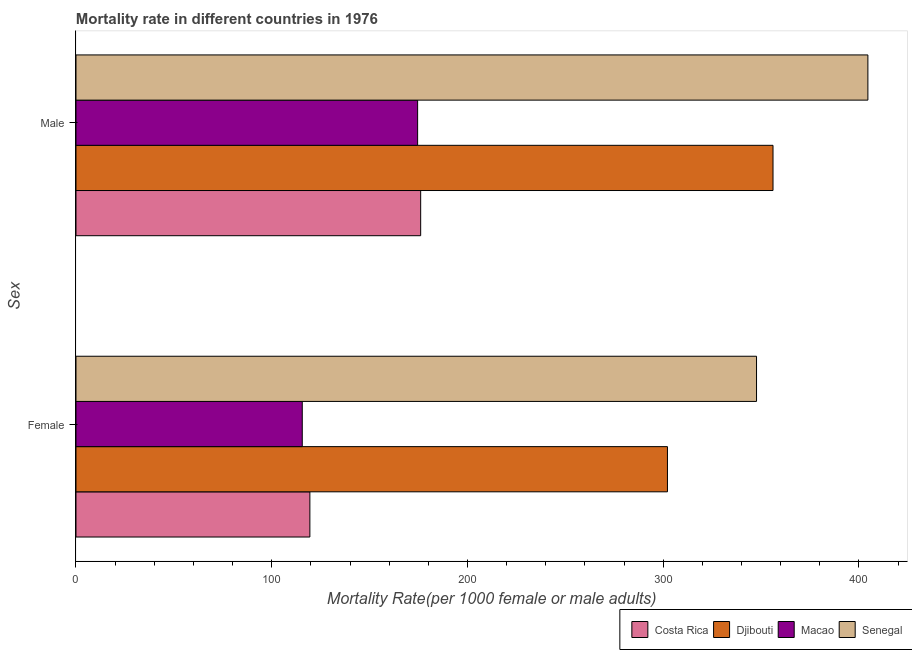How many groups of bars are there?
Your answer should be compact. 2. Are the number of bars per tick equal to the number of legend labels?
Make the answer very short. Yes. How many bars are there on the 1st tick from the top?
Your answer should be compact. 4. What is the male mortality rate in Senegal?
Your response must be concise. 404.62. Across all countries, what is the maximum female mortality rate?
Provide a short and direct response. 347.72. Across all countries, what is the minimum male mortality rate?
Keep it short and to the point. 174.55. In which country was the male mortality rate maximum?
Your response must be concise. Senegal. In which country was the male mortality rate minimum?
Give a very brief answer. Macao. What is the total male mortality rate in the graph?
Provide a short and direct response. 1111.42. What is the difference between the male mortality rate in Costa Rica and that in Senegal?
Provide a short and direct response. -228.51. What is the difference between the male mortality rate in Costa Rica and the female mortality rate in Senegal?
Give a very brief answer. -171.61. What is the average male mortality rate per country?
Your answer should be very brief. 277.85. What is the difference between the male mortality rate and female mortality rate in Costa Rica?
Give a very brief answer. 56.61. In how many countries, is the female mortality rate greater than 180 ?
Ensure brevity in your answer.  2. What is the ratio of the female mortality rate in Costa Rica to that in Senegal?
Provide a succinct answer. 0.34. Is the female mortality rate in Costa Rica less than that in Djibouti?
Make the answer very short. Yes. In how many countries, is the female mortality rate greater than the average female mortality rate taken over all countries?
Ensure brevity in your answer.  2. What does the 2nd bar from the top in Male represents?
Ensure brevity in your answer.  Macao. Are all the bars in the graph horizontal?
Offer a terse response. Yes. How many countries are there in the graph?
Your answer should be very brief. 4. What is the difference between two consecutive major ticks on the X-axis?
Provide a succinct answer. 100. Are the values on the major ticks of X-axis written in scientific E-notation?
Provide a succinct answer. No. Does the graph contain any zero values?
Your answer should be compact. No. Does the graph contain grids?
Provide a succinct answer. No. How many legend labels are there?
Give a very brief answer. 4. How are the legend labels stacked?
Give a very brief answer. Horizontal. What is the title of the graph?
Provide a short and direct response. Mortality rate in different countries in 1976. Does "Netherlands" appear as one of the legend labels in the graph?
Offer a very short reply. No. What is the label or title of the X-axis?
Give a very brief answer. Mortality Rate(per 1000 female or male adults). What is the label or title of the Y-axis?
Your answer should be very brief. Sex. What is the Mortality Rate(per 1000 female or male adults) of Costa Rica in Female?
Offer a terse response. 119.5. What is the Mortality Rate(per 1000 female or male adults) in Djibouti in Female?
Offer a very short reply. 302.2. What is the Mortality Rate(per 1000 female or male adults) of Macao in Female?
Offer a terse response. 115.61. What is the Mortality Rate(per 1000 female or male adults) of Senegal in Female?
Your response must be concise. 347.72. What is the Mortality Rate(per 1000 female or male adults) in Costa Rica in Male?
Offer a very short reply. 176.11. What is the Mortality Rate(per 1000 female or male adults) of Djibouti in Male?
Provide a succinct answer. 356.14. What is the Mortality Rate(per 1000 female or male adults) of Macao in Male?
Ensure brevity in your answer.  174.55. What is the Mortality Rate(per 1000 female or male adults) of Senegal in Male?
Keep it short and to the point. 404.62. Across all Sex, what is the maximum Mortality Rate(per 1000 female or male adults) of Costa Rica?
Offer a very short reply. 176.11. Across all Sex, what is the maximum Mortality Rate(per 1000 female or male adults) of Djibouti?
Keep it short and to the point. 356.14. Across all Sex, what is the maximum Mortality Rate(per 1000 female or male adults) of Macao?
Ensure brevity in your answer.  174.55. Across all Sex, what is the maximum Mortality Rate(per 1000 female or male adults) in Senegal?
Offer a terse response. 404.62. Across all Sex, what is the minimum Mortality Rate(per 1000 female or male adults) of Costa Rica?
Make the answer very short. 119.5. Across all Sex, what is the minimum Mortality Rate(per 1000 female or male adults) in Djibouti?
Your answer should be compact. 302.2. Across all Sex, what is the minimum Mortality Rate(per 1000 female or male adults) in Macao?
Offer a terse response. 115.61. Across all Sex, what is the minimum Mortality Rate(per 1000 female or male adults) of Senegal?
Your answer should be compact. 347.72. What is the total Mortality Rate(per 1000 female or male adults) of Costa Rica in the graph?
Ensure brevity in your answer.  295.61. What is the total Mortality Rate(per 1000 female or male adults) in Djibouti in the graph?
Provide a succinct answer. 658.34. What is the total Mortality Rate(per 1000 female or male adults) of Macao in the graph?
Provide a succinct answer. 290.16. What is the total Mortality Rate(per 1000 female or male adults) of Senegal in the graph?
Your answer should be very brief. 752.34. What is the difference between the Mortality Rate(per 1000 female or male adults) in Costa Rica in Female and that in Male?
Offer a terse response. -56.61. What is the difference between the Mortality Rate(per 1000 female or male adults) of Djibouti in Female and that in Male?
Give a very brief answer. -53.93. What is the difference between the Mortality Rate(per 1000 female or male adults) of Macao in Female and that in Male?
Ensure brevity in your answer.  -58.94. What is the difference between the Mortality Rate(per 1000 female or male adults) of Senegal in Female and that in Male?
Your answer should be very brief. -56.9. What is the difference between the Mortality Rate(per 1000 female or male adults) in Costa Rica in Female and the Mortality Rate(per 1000 female or male adults) in Djibouti in Male?
Keep it short and to the point. -236.64. What is the difference between the Mortality Rate(per 1000 female or male adults) of Costa Rica in Female and the Mortality Rate(per 1000 female or male adults) of Macao in Male?
Offer a terse response. -55.05. What is the difference between the Mortality Rate(per 1000 female or male adults) of Costa Rica in Female and the Mortality Rate(per 1000 female or male adults) of Senegal in Male?
Offer a terse response. -285.12. What is the difference between the Mortality Rate(per 1000 female or male adults) of Djibouti in Female and the Mortality Rate(per 1000 female or male adults) of Macao in Male?
Ensure brevity in your answer.  127.65. What is the difference between the Mortality Rate(per 1000 female or male adults) in Djibouti in Female and the Mortality Rate(per 1000 female or male adults) in Senegal in Male?
Your answer should be compact. -102.41. What is the difference between the Mortality Rate(per 1000 female or male adults) in Macao in Female and the Mortality Rate(per 1000 female or male adults) in Senegal in Male?
Provide a succinct answer. -289.01. What is the average Mortality Rate(per 1000 female or male adults) in Costa Rica per Sex?
Offer a terse response. 147.8. What is the average Mortality Rate(per 1000 female or male adults) in Djibouti per Sex?
Your answer should be very brief. 329.17. What is the average Mortality Rate(per 1000 female or male adults) in Macao per Sex?
Offer a very short reply. 145.08. What is the average Mortality Rate(per 1000 female or male adults) of Senegal per Sex?
Give a very brief answer. 376.17. What is the difference between the Mortality Rate(per 1000 female or male adults) in Costa Rica and Mortality Rate(per 1000 female or male adults) in Djibouti in Female?
Your response must be concise. -182.71. What is the difference between the Mortality Rate(per 1000 female or male adults) of Costa Rica and Mortality Rate(per 1000 female or male adults) of Macao in Female?
Give a very brief answer. 3.89. What is the difference between the Mortality Rate(per 1000 female or male adults) in Costa Rica and Mortality Rate(per 1000 female or male adults) in Senegal in Female?
Make the answer very short. -228.22. What is the difference between the Mortality Rate(per 1000 female or male adults) of Djibouti and Mortality Rate(per 1000 female or male adults) of Macao in Female?
Offer a very short reply. 186.59. What is the difference between the Mortality Rate(per 1000 female or male adults) of Djibouti and Mortality Rate(per 1000 female or male adults) of Senegal in Female?
Provide a succinct answer. -45.51. What is the difference between the Mortality Rate(per 1000 female or male adults) of Macao and Mortality Rate(per 1000 female or male adults) of Senegal in Female?
Provide a short and direct response. -232.11. What is the difference between the Mortality Rate(per 1000 female or male adults) of Costa Rica and Mortality Rate(per 1000 female or male adults) of Djibouti in Male?
Offer a very short reply. -180.03. What is the difference between the Mortality Rate(per 1000 female or male adults) of Costa Rica and Mortality Rate(per 1000 female or male adults) of Macao in Male?
Your response must be concise. 1.56. What is the difference between the Mortality Rate(per 1000 female or male adults) in Costa Rica and Mortality Rate(per 1000 female or male adults) in Senegal in Male?
Make the answer very short. -228.51. What is the difference between the Mortality Rate(per 1000 female or male adults) in Djibouti and Mortality Rate(per 1000 female or male adults) in Macao in Male?
Your answer should be compact. 181.59. What is the difference between the Mortality Rate(per 1000 female or male adults) in Djibouti and Mortality Rate(per 1000 female or male adults) in Senegal in Male?
Offer a terse response. -48.48. What is the difference between the Mortality Rate(per 1000 female or male adults) in Macao and Mortality Rate(per 1000 female or male adults) in Senegal in Male?
Provide a succinct answer. -230.07. What is the ratio of the Mortality Rate(per 1000 female or male adults) in Costa Rica in Female to that in Male?
Give a very brief answer. 0.68. What is the ratio of the Mortality Rate(per 1000 female or male adults) of Djibouti in Female to that in Male?
Your response must be concise. 0.85. What is the ratio of the Mortality Rate(per 1000 female or male adults) in Macao in Female to that in Male?
Offer a terse response. 0.66. What is the ratio of the Mortality Rate(per 1000 female or male adults) in Senegal in Female to that in Male?
Make the answer very short. 0.86. What is the difference between the highest and the second highest Mortality Rate(per 1000 female or male adults) of Costa Rica?
Offer a very short reply. 56.61. What is the difference between the highest and the second highest Mortality Rate(per 1000 female or male adults) of Djibouti?
Keep it short and to the point. 53.93. What is the difference between the highest and the second highest Mortality Rate(per 1000 female or male adults) of Macao?
Your answer should be very brief. 58.94. What is the difference between the highest and the second highest Mortality Rate(per 1000 female or male adults) of Senegal?
Provide a short and direct response. 56.9. What is the difference between the highest and the lowest Mortality Rate(per 1000 female or male adults) of Costa Rica?
Provide a short and direct response. 56.61. What is the difference between the highest and the lowest Mortality Rate(per 1000 female or male adults) of Djibouti?
Give a very brief answer. 53.93. What is the difference between the highest and the lowest Mortality Rate(per 1000 female or male adults) in Macao?
Offer a very short reply. 58.94. What is the difference between the highest and the lowest Mortality Rate(per 1000 female or male adults) in Senegal?
Your answer should be compact. 56.9. 